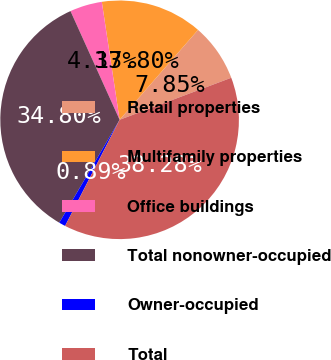Convert chart. <chart><loc_0><loc_0><loc_500><loc_500><pie_chart><fcel>Retail properties<fcel>Multifamily properties<fcel>Office buildings<fcel>Total nonowner-occupied<fcel>Owner-occupied<fcel>Total<nl><fcel>7.85%<fcel>13.8%<fcel>4.37%<fcel>34.8%<fcel>0.89%<fcel>38.28%<nl></chart> 